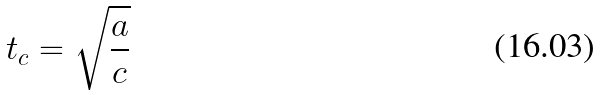<formula> <loc_0><loc_0><loc_500><loc_500>t _ { c } = \sqrt { \frac { a } { c } }</formula> 